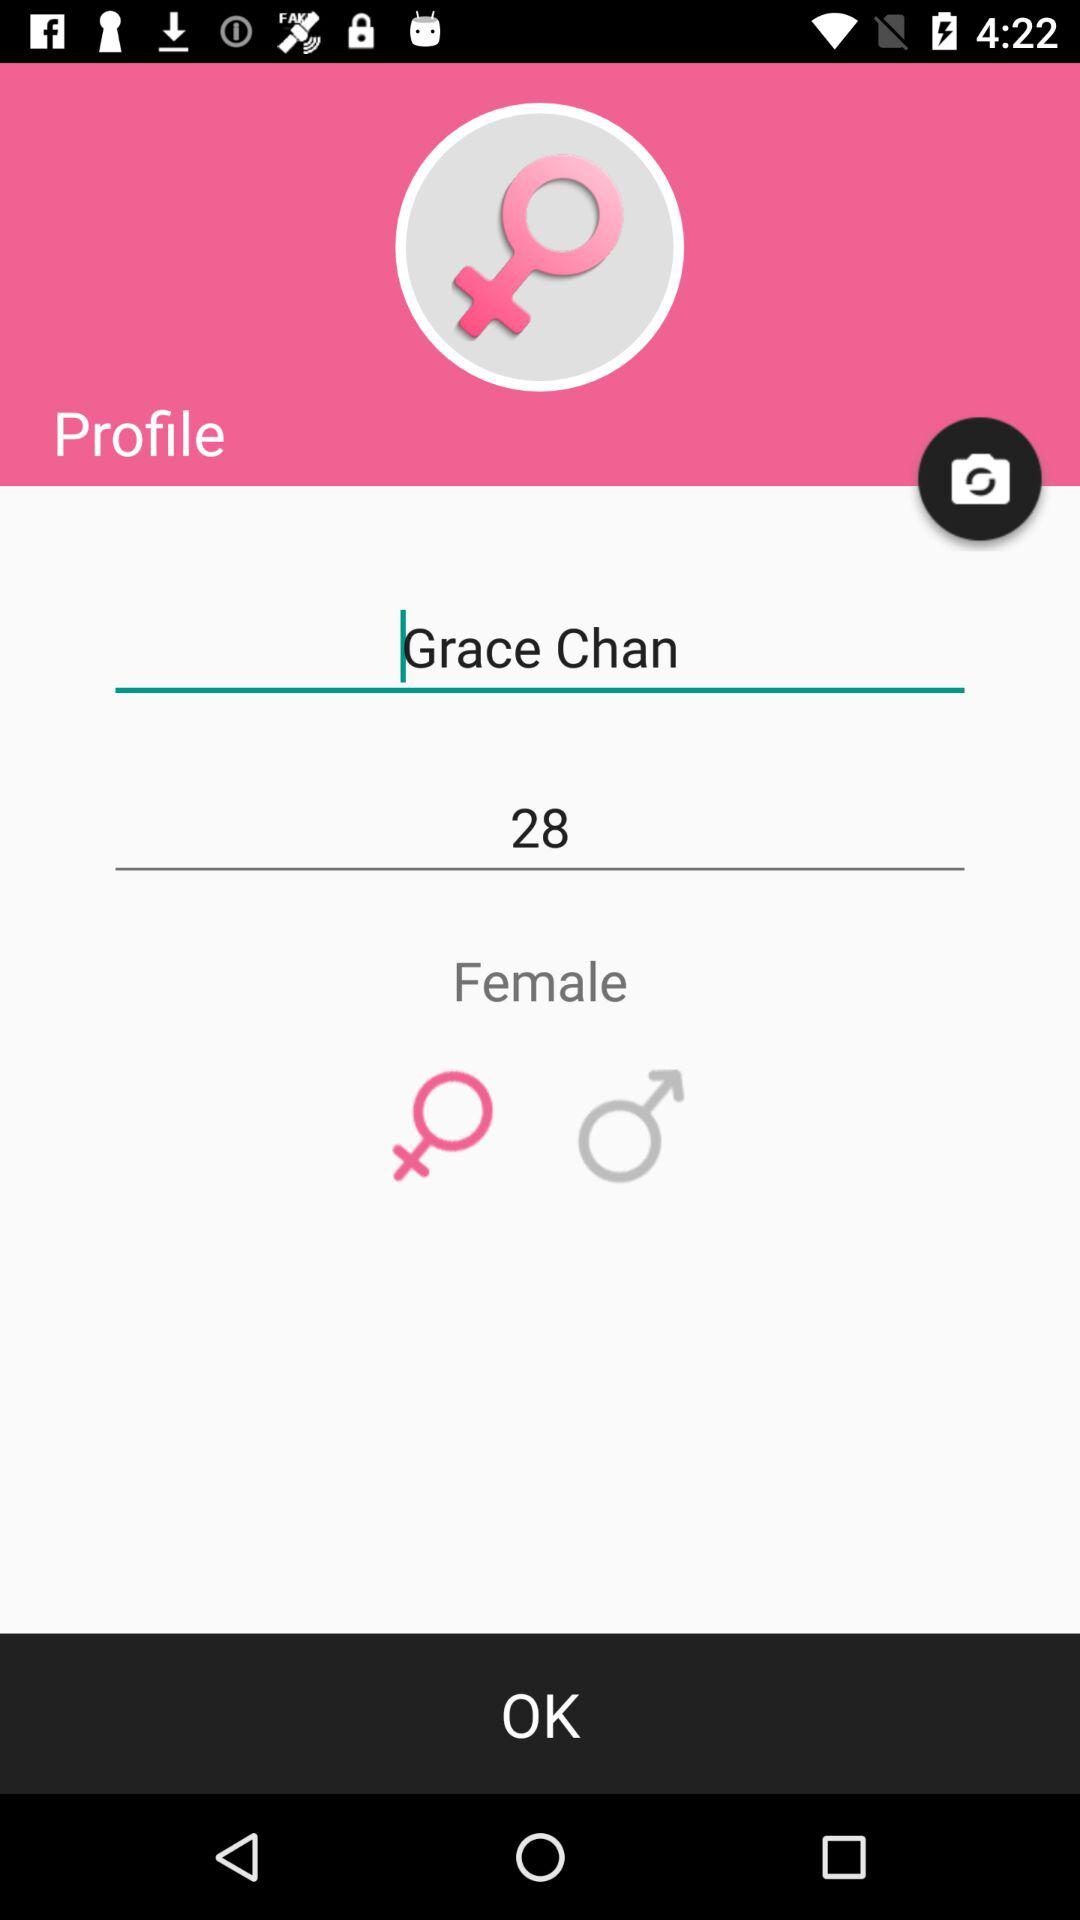How tall is Grace Chan?
When the provided information is insufficient, respond with <no answer>. <no answer> 